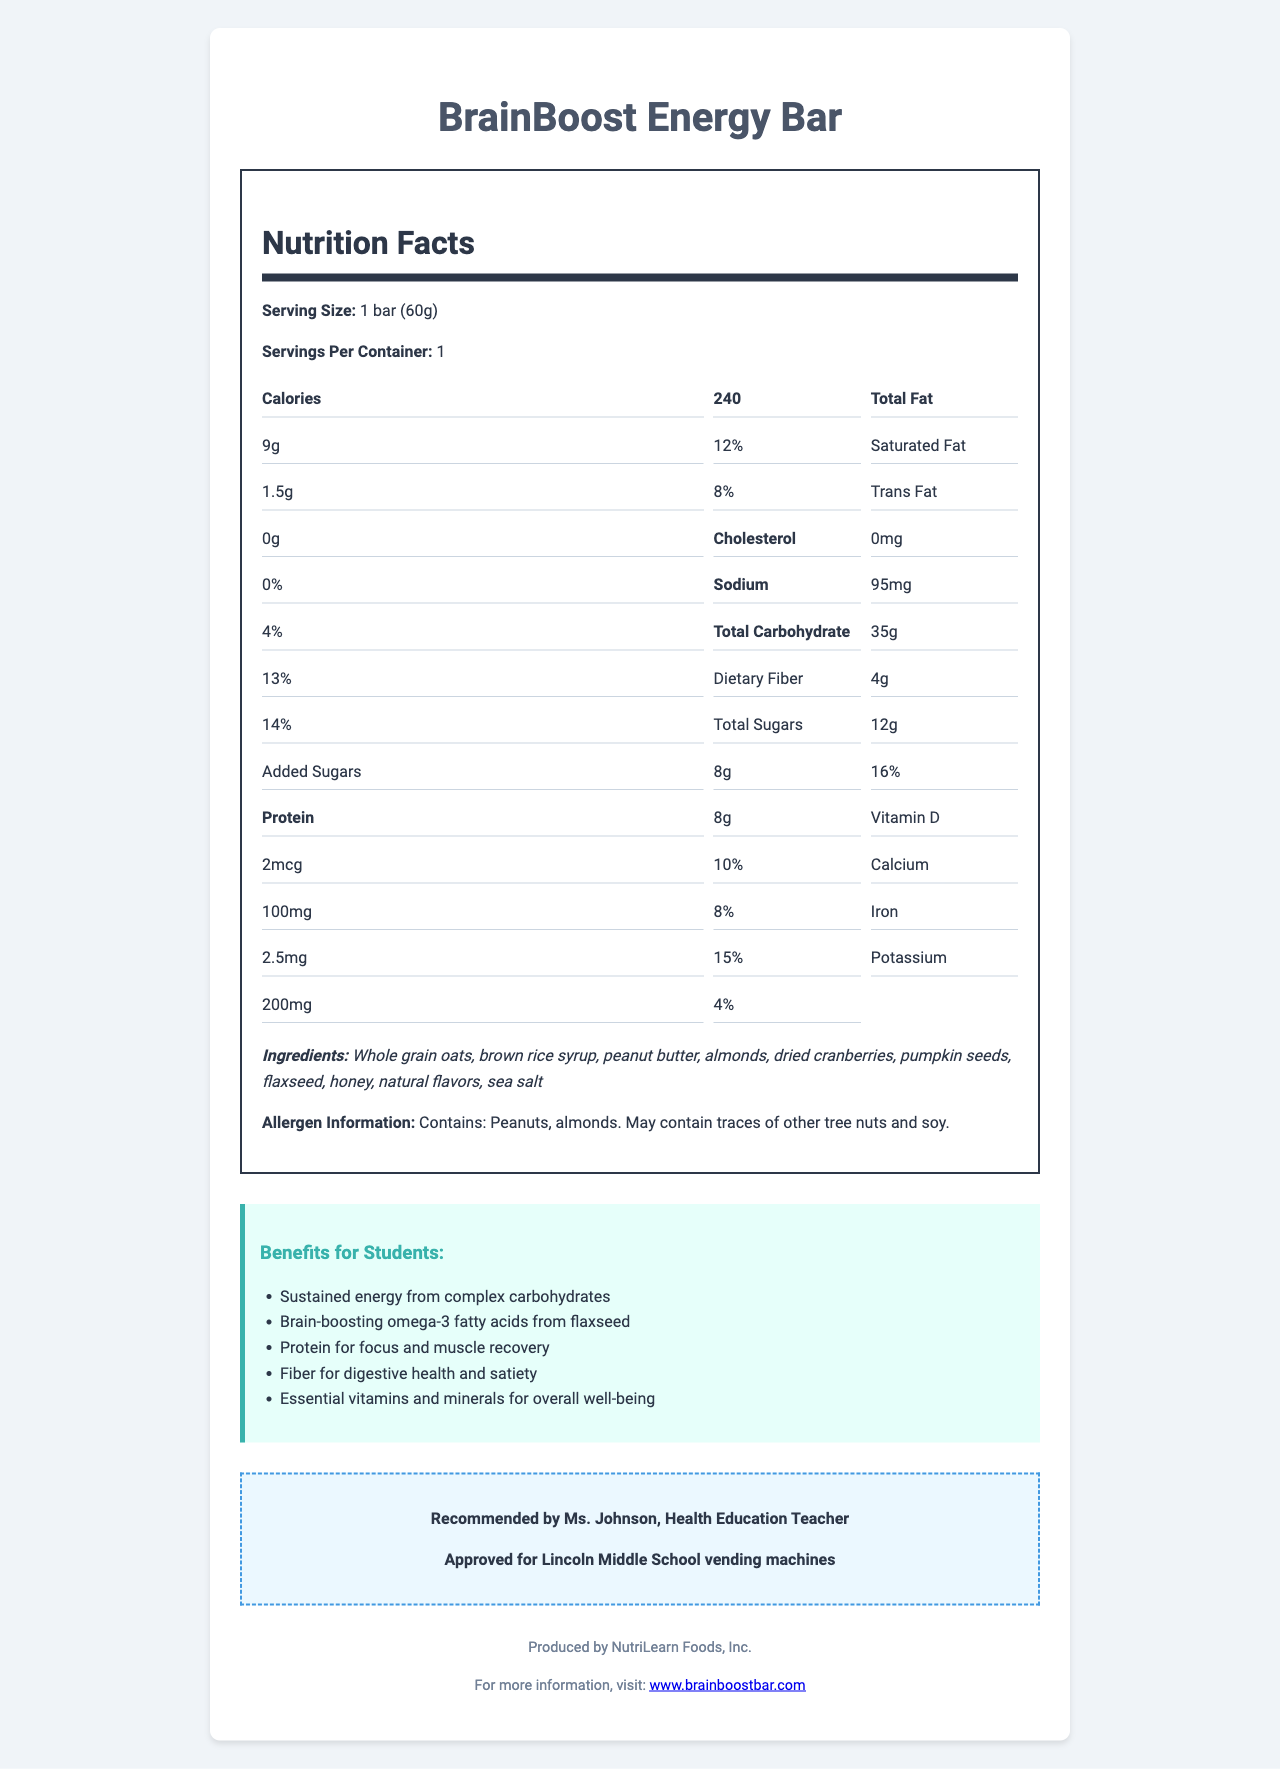what is the serving size of the BrainBoost Energy Bar? The serving size is specified at the beginning of the nutrition facts label.
Answer: 1 bar (60g) How many calories does the BrainBoost Energy Bar contain? The calories are listed prominently in the nutrition facts section of the document.
Answer: 240 What percentage of the daily value of Total Fat does one BrainBoost Energy Bar provide? The daily value percentage for Total Fat can be found next to the amount of Total Fat listed as "9g".
Answer: 12% What allergens does this energy bar contain? The allergen information is clearly stated at the bottom of the nutrition label.
Answer: Peanuts, almonds. May contain traces of other tree nuts and soy. What is the amount of protein in one BrainBoost Energy Bar? The amount of protein is listed in the nutrition facts section.
Answer: 8g What are some of the benefits of the BrainBoost Energy Bar for students? These benefits are listed in the "Benefits for Students" section of the document.
Answer: Sustained energy from complex carbohydrates, Brain-boosting omega-3 fatty acids from flaxseed, Protein for focus and muscle recovery, Fiber for digestive health and satiety, Essential vitamins and minerals for overall well-being Which of the following vitamins or minerals does the BrainBoost Energy Bar provide? A. Vitamin A B. Vitamin D C. Vitamin C The nutrition facts label specifies that the bar provides Vitamin D (2mcg, 10% daily value).
Answer: B. Vitamin D What is the main idea of the BrainBoost Energy Bar document? The overall document summarization includes nutritional information, benefits, endorsements, and school approval.
Answer: The document provides detailed nutrition facts about the BrainBoost Energy Bar, emphasizes its health benefits for active students, mentions teacher endorsement, and states its approval for school vending machines. Is the BrainBoost Energy Bar cholesterol-free? The nutrition facts section lists 0mg of cholesterol and 0% daily value, indicating that it is cholesterol-free.
Answer: Yes What is the source of brain-boosting omega-3 fatty acids in the energy bar? The "Benefits for Students" section mentions omega-3 fatty acids are from flaxseed.
Answer: Flaxseed Can we determine the price of the BrainBoost Energy Bar from this document? The document does not provide any pricing information.
Answer: Not enough information What percentage of the daily value of Iron does one BrainBoost Energy Bar provide? The daily value percentage for Iron is given in the nutrition facts section.
Answer: 15% How much dietary fiber is in one serving of the BrainBoost Energy Bar? The amount of dietary fiber is listed in the nutrition facts section.
Answer: 4g Which of these ingredients is not found in the BrainBoost Energy Bar? A. Whole grain oats B. Brown sugar C. Pumpkin seeds The list of ingredients does not include brown sugar but does mention others like whole grain oats and pumpkin seeds.
Answer: B. Brown sugar 